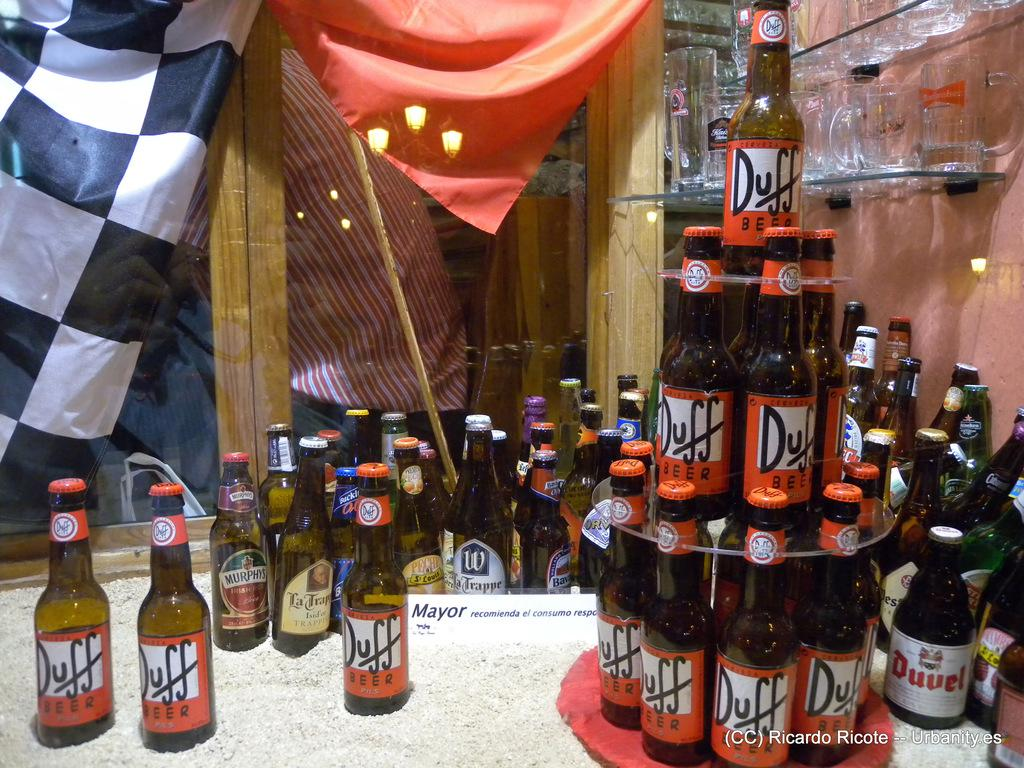What can be seen on the right side of the image? There are many bottles on the right side of the image. What is visible in the background of the image? There are many glasses in the background of the image. What feature allows natural light to enter the space in the image? There is a window in the image. What provides illumination in the image? There is a light source in the image. Who or what is present in the image? There is a person in the image. What type of material is visible in the image? There is cloth visible in the image. How many oranges are being held by the stranger in the image? There is no stranger or oranges present in the image. What type of insect can be seen crawling on the cloth in the image? There is no insect present in the image; only bottles, glasses, a window, a light source, a person, and cloth are visible. 